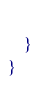<code> <loc_0><loc_0><loc_500><loc_500><_C#_>        
    }
}</code> 